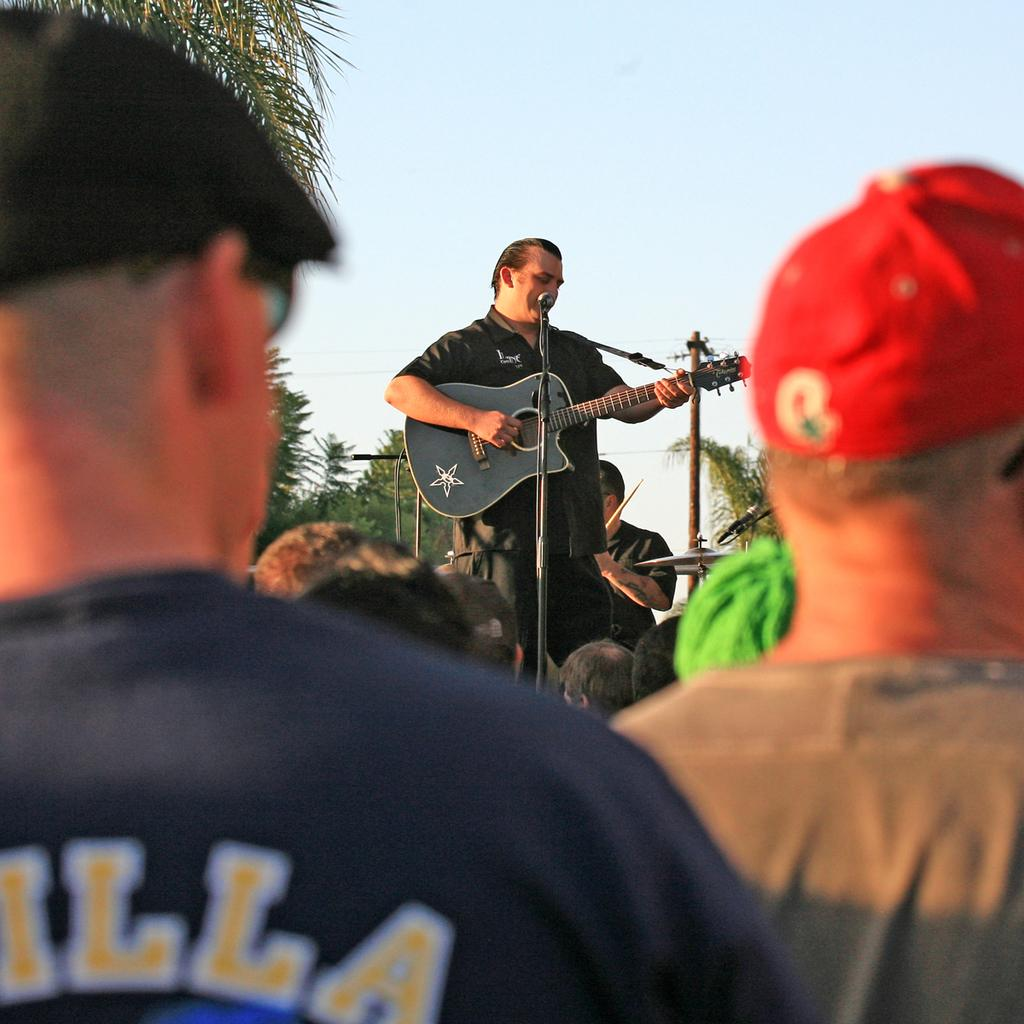What is the man in the image holding? The man is holding a guitar. What is the man doing with the guitar? The man is playing the guitar. What other object is present in the image related to the man's activity? There is a microphone in the image. Can you describe the appearance of the other two people in the image? The two other people are wearing red and black color hats. How does the kitten contribute to the musical performance in the image? There is no kitten present in the image, so it cannot contribute to the musical performance. 